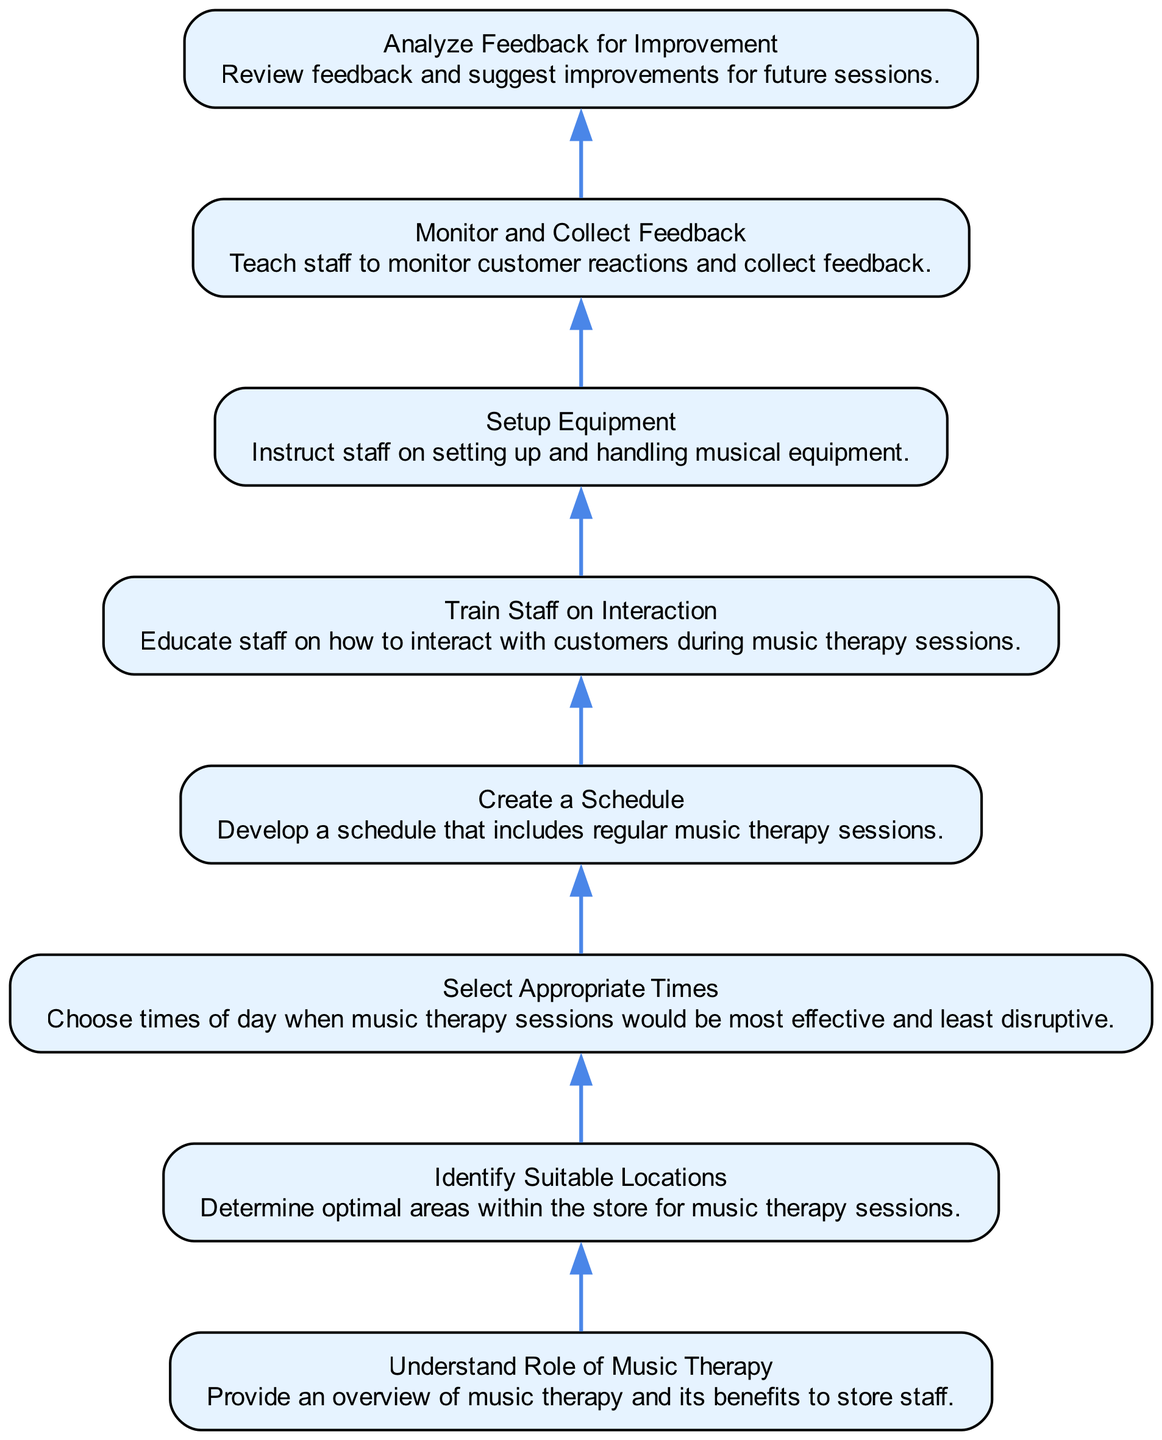What is the first step in the training process? The first step is "Understand Role of Music Therapy," which provides an overview of music therapy and its benefits to store staff.
Answer: Understand Role of Music Therapy How many elements are in the diagram? There are eight elements shown in the diagram that are related to training store staff for music therapy sessions.
Answer: Eight What element comes after “Setup Equipment”? The element that follows "Setup Equipment" is "Monitor and Collect Feedback," indicating the next step in the training process.
Answer: Monitor and Collect Feedback What is the last step in the training flow? The last step in the training flow is "Analyze Feedback for Improvement," where staff review feedback and suggest improvements for future sessions.
Answer: Analyze Feedback for Improvement Which element involves educating staff on customer interaction? The element focused on educating staff on interaction with customers during music therapy sessions is "Train Staff on Interaction."
Answer: Train Staff on Interaction If staff have completed the training, which element will they look at next? After completing the training, staff would look at "Monitor and Collect Feedback," as it is the next element in the flow after "Setup Equipment."
Answer: Monitor and Collect Feedback Which two elements are directly connected to "Create a Schedule"? "Select Appropriate Times" leads into "Create a Schedule," and "Train Staff on Interaction" follows "Create a Schedule," forming direct connections.
Answer: Select Appropriate Times, Train Staff on Interaction What is the purpose of “Analyze Feedback for Improvement”? The purpose of this step is to review feedback and suggest improvements for future music therapy sessions, enhancing the quality of the training.
Answer: Review feedback and suggest improvements 